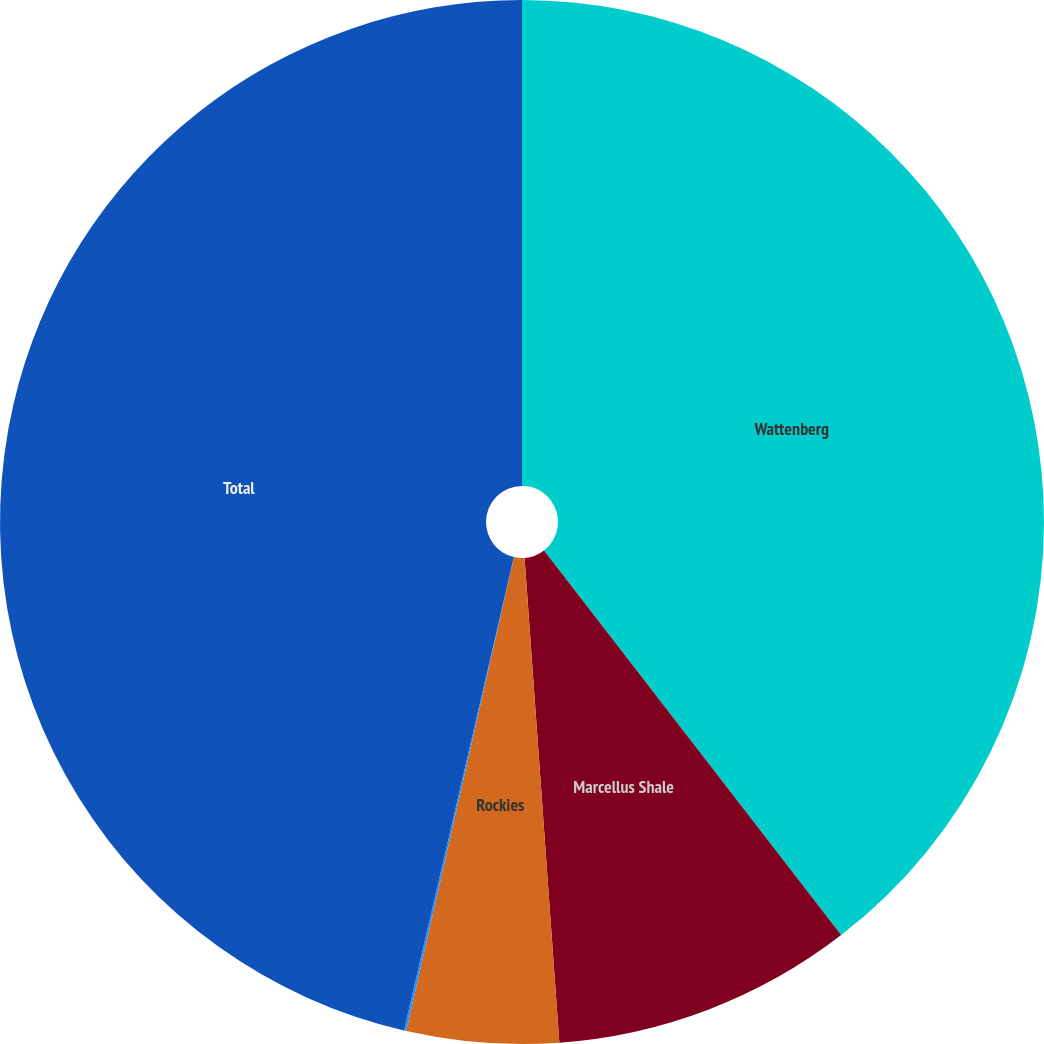Convert chart. <chart><loc_0><loc_0><loc_500><loc_500><pie_chart><fcel>Wattenberg<fcel>Marcellus Shale<fcel>Rockies<fcel>Deepwater Gulf of Mexico<fcel>Total<nl><fcel>39.53%<fcel>9.33%<fcel>4.7%<fcel>0.07%<fcel>46.37%<nl></chart> 